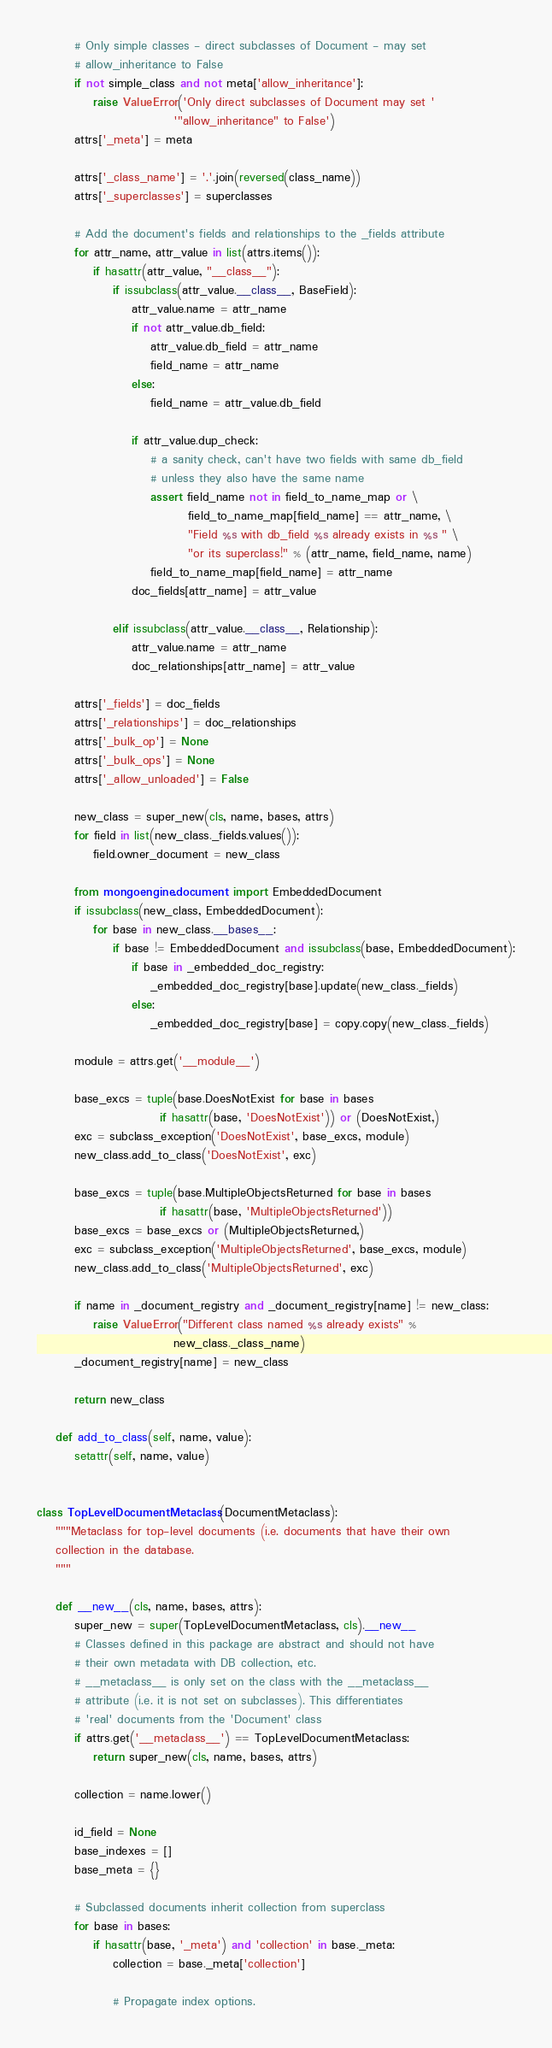Convert code to text. <code><loc_0><loc_0><loc_500><loc_500><_Python_>        # Only simple classes - direct subclasses of Document - may set
        # allow_inheritance to False
        if not simple_class and not meta['allow_inheritance']:
            raise ValueError('Only direct subclasses of Document may set '
                             '"allow_inheritance" to False')
        attrs['_meta'] = meta

        attrs['_class_name'] = '.'.join(reversed(class_name))
        attrs['_superclasses'] = superclasses

        # Add the document's fields and relationships to the _fields attribute
        for attr_name, attr_value in list(attrs.items()):
            if hasattr(attr_value, "__class__"):
                if issubclass(attr_value.__class__, BaseField):
                    attr_value.name = attr_name
                    if not attr_value.db_field:
                        attr_value.db_field = attr_name
                        field_name = attr_name
                    else:
                        field_name = attr_value.db_field

                    if attr_value.dup_check:
                        # a sanity check, can't have two fields with same db_field
                        # unless they also have the same name
                        assert field_name not in field_to_name_map or \
                                field_to_name_map[field_name] == attr_name, \
                                "Field %s with db_field %s already exists in %s " \
                                "or its superclass!" % (attr_name, field_name, name)
                        field_to_name_map[field_name] = attr_name
                    doc_fields[attr_name] = attr_value

                elif issubclass(attr_value.__class__, Relationship):
                    attr_value.name = attr_name
                    doc_relationships[attr_name] = attr_value

        attrs['_fields'] = doc_fields
        attrs['_relationships'] = doc_relationships
        attrs['_bulk_op'] = None
        attrs['_bulk_ops'] = None
        attrs['_allow_unloaded'] = False

        new_class = super_new(cls, name, bases, attrs)
        for field in list(new_class._fields.values()):
            field.owner_document = new_class

        from mongoengine.document import EmbeddedDocument
        if issubclass(new_class, EmbeddedDocument):
            for base in new_class.__bases__:
                if base != EmbeddedDocument and issubclass(base, EmbeddedDocument):
                    if base in _embedded_doc_registry:
                        _embedded_doc_registry[base].update(new_class._fields)
                    else:
                        _embedded_doc_registry[base] = copy.copy(new_class._fields)

        module = attrs.get('__module__')

        base_excs = tuple(base.DoesNotExist for base in bases
                          if hasattr(base, 'DoesNotExist')) or (DoesNotExist,)
        exc = subclass_exception('DoesNotExist', base_excs, module)
        new_class.add_to_class('DoesNotExist', exc)

        base_excs = tuple(base.MultipleObjectsReturned for base in bases
                          if hasattr(base, 'MultipleObjectsReturned'))
        base_excs = base_excs or (MultipleObjectsReturned,)
        exc = subclass_exception('MultipleObjectsReturned', base_excs, module)
        new_class.add_to_class('MultipleObjectsReturned', exc)

        if name in _document_registry and _document_registry[name] != new_class:
            raise ValueError("Different class named %s already exists" %
                             new_class._class_name)
        _document_registry[name] = new_class

        return new_class

    def add_to_class(self, name, value):
        setattr(self, name, value)


class TopLevelDocumentMetaclass(DocumentMetaclass):
    """Metaclass for top-level documents (i.e. documents that have their own
    collection in the database.
    """

    def __new__(cls, name, bases, attrs):
        super_new = super(TopLevelDocumentMetaclass, cls).__new__
        # Classes defined in this package are abstract and should not have
        # their own metadata with DB collection, etc.
        # __metaclass__ is only set on the class with the __metaclass__
        # attribute (i.e. it is not set on subclasses). This differentiates
        # 'real' documents from the 'Document' class
        if attrs.get('__metaclass__') == TopLevelDocumentMetaclass:
            return super_new(cls, name, bases, attrs)

        collection = name.lower()

        id_field = None
        base_indexes = []
        base_meta = {}

        # Subclassed documents inherit collection from superclass
        for base in bases:
            if hasattr(base, '_meta') and 'collection' in base._meta:
                collection = base._meta['collection']

                # Propagate index options.</code> 